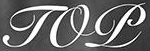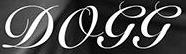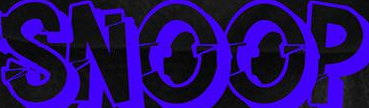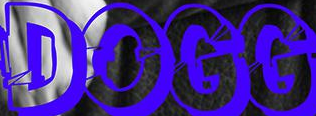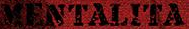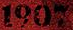Read the text content from these images in order, separated by a semicolon. TOP; DOGG; SNOOP; DOGG; MENTALITA; 1907 